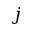<formula> <loc_0><loc_0><loc_500><loc_500>j</formula> 